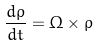Convert formula to latex. <formula><loc_0><loc_0><loc_500><loc_500>\frac { d \rho } { d t } = \Omega \times \rho</formula> 